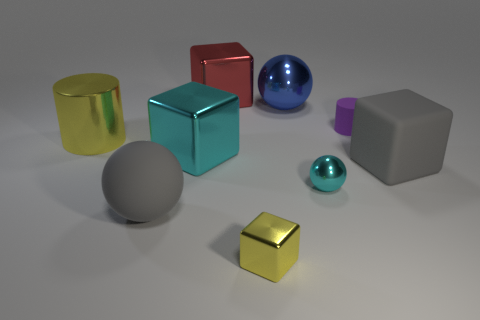Subtract all purple cubes. Subtract all purple balls. How many cubes are left? 4 Add 1 red rubber cubes. How many objects exist? 10 Subtract all cubes. How many objects are left? 5 Add 8 big red cubes. How many big red cubes exist? 9 Subtract 0 red cylinders. How many objects are left? 9 Subtract all small gray rubber objects. Subtract all large metallic balls. How many objects are left? 8 Add 5 tiny metal balls. How many tiny metal balls are left? 6 